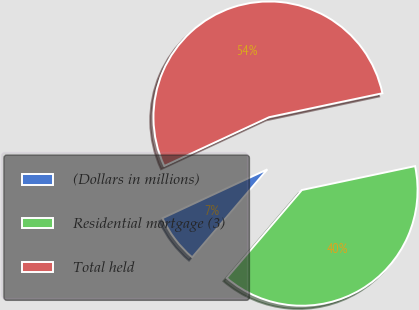<chart> <loc_0><loc_0><loc_500><loc_500><pie_chart><fcel>(Dollars in millions)<fcel>Residential mortgage (3)<fcel>Total held<nl><fcel>6.81%<fcel>39.57%<fcel>53.62%<nl></chart> 